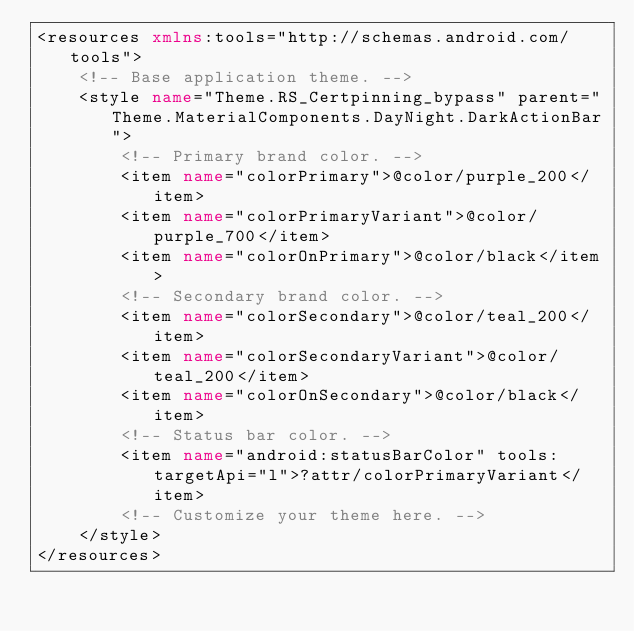Convert code to text. <code><loc_0><loc_0><loc_500><loc_500><_XML_><resources xmlns:tools="http://schemas.android.com/tools">
    <!-- Base application theme. -->
    <style name="Theme.RS_Certpinning_bypass" parent="Theme.MaterialComponents.DayNight.DarkActionBar">
        <!-- Primary brand color. -->
        <item name="colorPrimary">@color/purple_200</item>
        <item name="colorPrimaryVariant">@color/purple_700</item>
        <item name="colorOnPrimary">@color/black</item>
        <!-- Secondary brand color. -->
        <item name="colorSecondary">@color/teal_200</item>
        <item name="colorSecondaryVariant">@color/teal_200</item>
        <item name="colorOnSecondary">@color/black</item>
        <!-- Status bar color. -->
        <item name="android:statusBarColor" tools:targetApi="l">?attr/colorPrimaryVariant</item>
        <!-- Customize your theme here. -->
    </style>
</resources></code> 